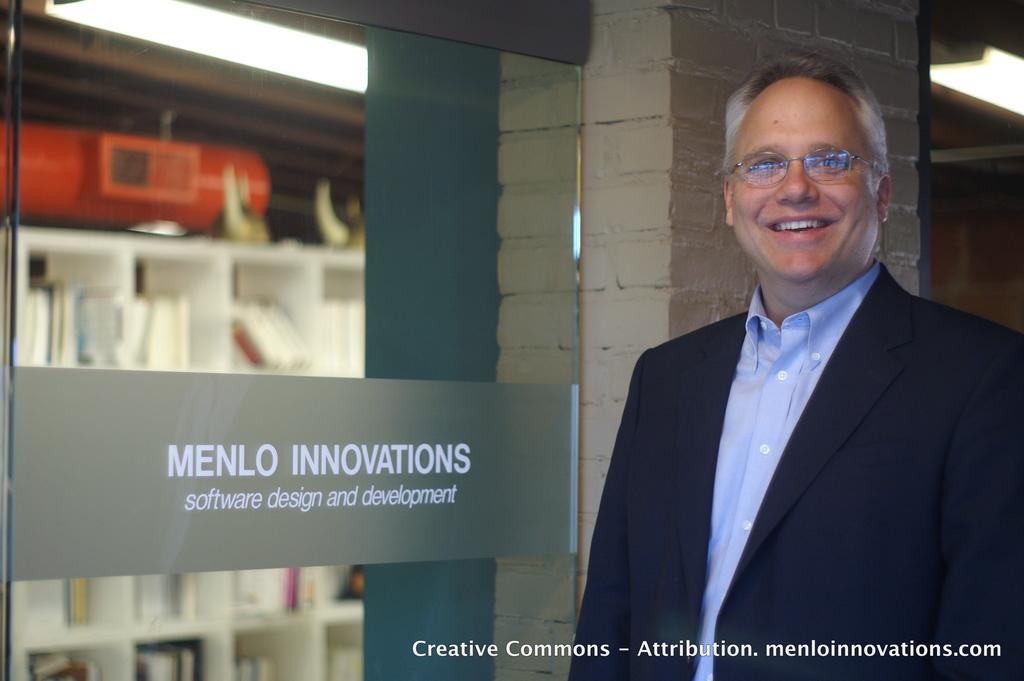Please provide a concise description of this image. On the right side of the image a man is standing. In the center of the image we can see glass door, shelves, books, machine, lights, wall are present. At the bottom of the image some text is there. 